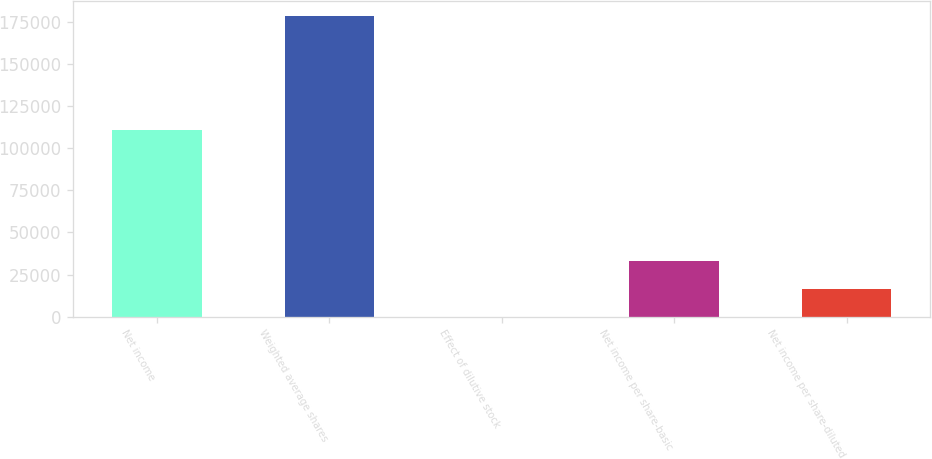Convert chart. <chart><loc_0><loc_0><loc_500><loc_500><bar_chart><fcel>Net income<fcel>Weighted average shares<fcel>Effect of dilutive stock<fcel>Net income per share-basic<fcel>Net income per share-diluted<nl><fcel>111006<fcel>178354<fcel>0.02<fcel>32951<fcel>16475.5<nl></chart> 